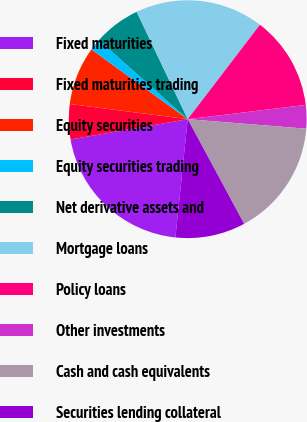<chart> <loc_0><loc_0><loc_500><loc_500><pie_chart><fcel>Fixed maturities<fcel>Fixed maturities trading<fcel>Equity securities<fcel>Equity securities trading<fcel>Net derivative assets and<fcel>Mortgage loans<fcel>Policy loans<fcel>Other investments<fcel>Cash and cash equivalents<fcel>Securities lending collateral<nl><fcel>20.62%<fcel>4.77%<fcel>7.94%<fcel>1.6%<fcel>6.36%<fcel>17.45%<fcel>12.69%<fcel>3.19%<fcel>15.86%<fcel>9.52%<nl></chart> 